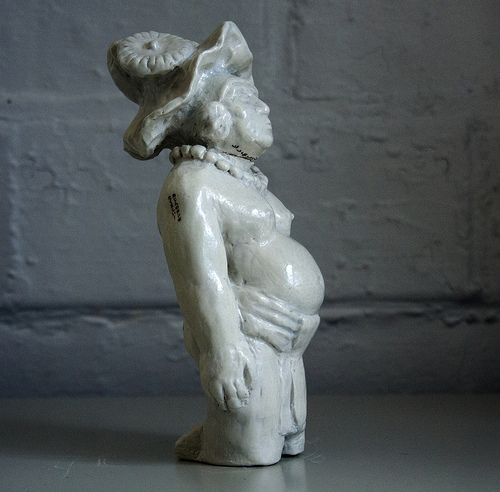<image>
Is the statue above the floor? No. The statue is not positioned above the floor. The vertical arrangement shows a different relationship. 